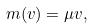Convert formula to latex. <formula><loc_0><loc_0><loc_500><loc_500>m ( v ) = \mu v ,</formula> 